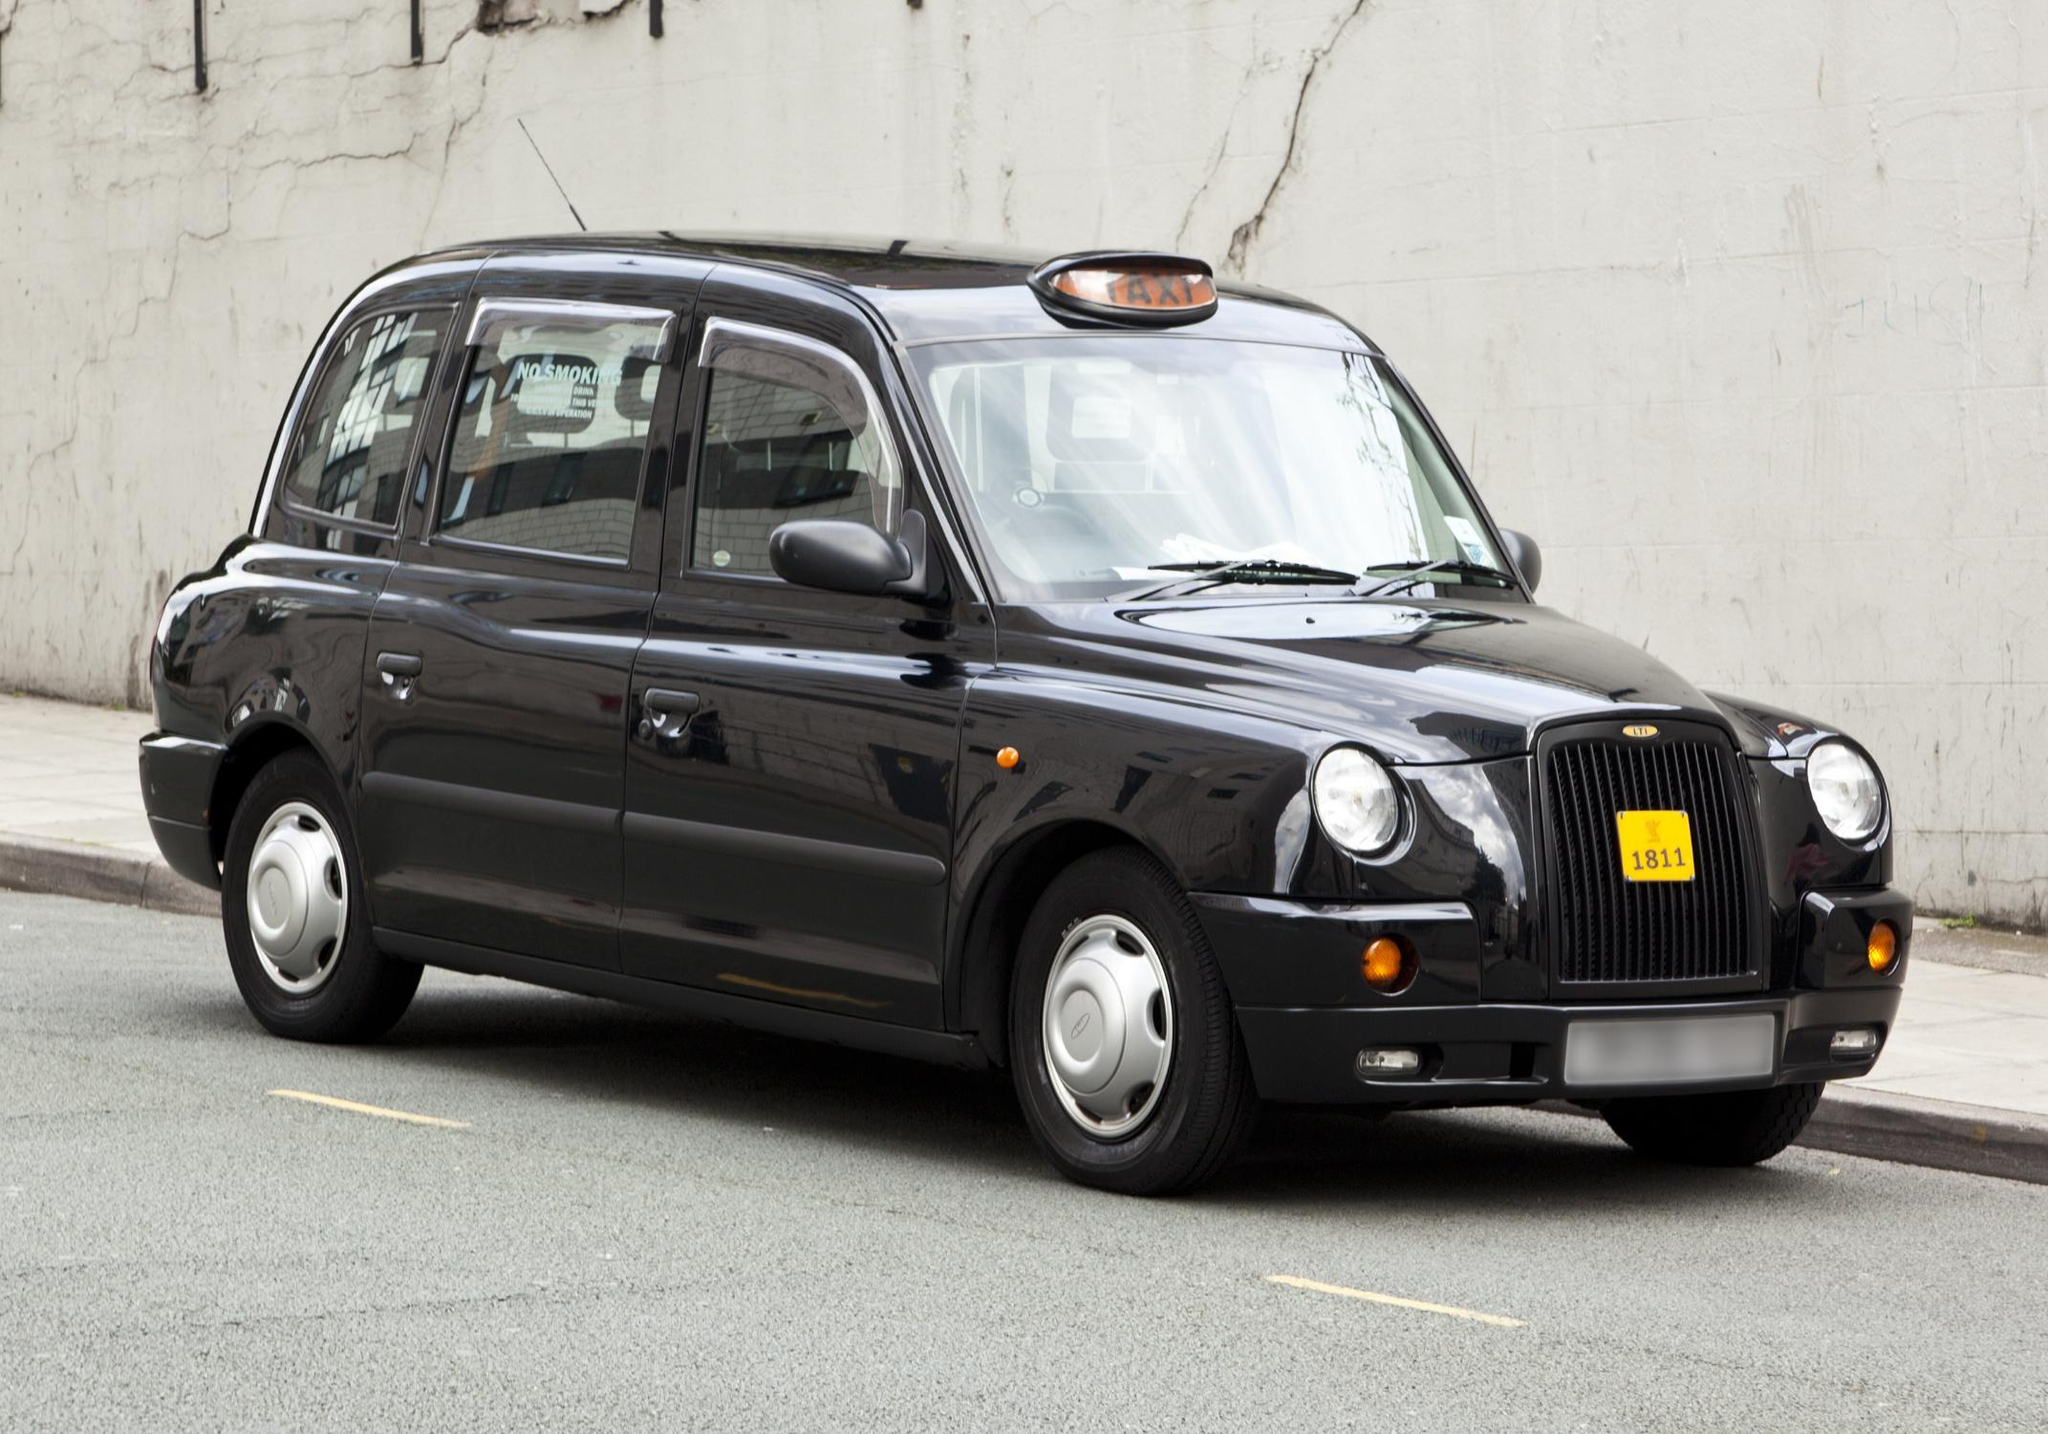Can you describe any unique features of this particular model of taxi? This model is a typical example of the TX4, a popular type amongst the London Black Cabs. Notable features include its distinctive boxy shape which provides ample internal space and headroom, making it ideal for passenger comfort. It's fitted with a diesel engine, designed for the stop-start nature of urban traffic. Safety features are robust, including high visibility of passengers and driver, and compliance with stringent London Public Carriage Office regulations. 